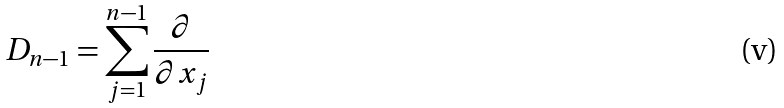Convert formula to latex. <formula><loc_0><loc_0><loc_500><loc_500>D _ { n - 1 } = \sum _ { j = 1 } ^ { n - 1 } \frac { \partial } { \partial x _ { j } }</formula> 